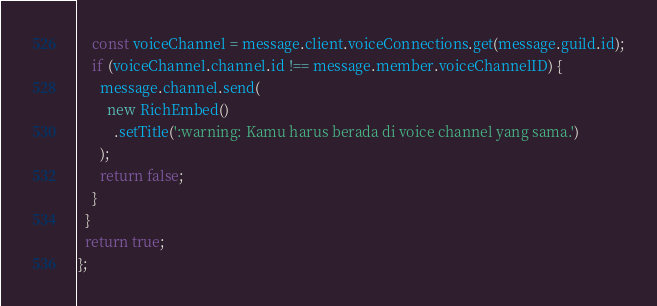Convert code to text. <code><loc_0><loc_0><loc_500><loc_500><_JavaScript_>    const voiceChannel = message.client.voiceConnections.get(message.guild.id);
    if (voiceChannel.channel.id !== message.member.voiceChannelID) {
      message.channel.send(
        new RichEmbed()
          .setTitle(':warning: Kamu harus berada di voice channel yang sama.')
      );
      return false;
    }
  }
  return true;
};</code> 